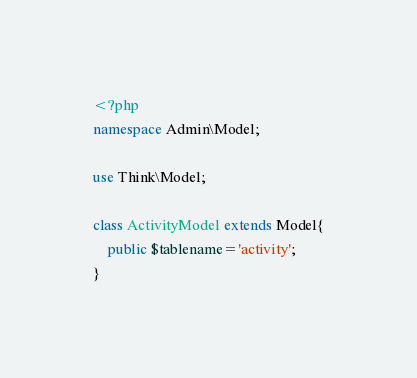Convert code to text. <code><loc_0><loc_0><loc_500><loc_500><_PHP_><?php
namespace Admin\Model;

use Think\Model;

class ActivityModel extends Model{
	public $tablename='activity';
}</code> 